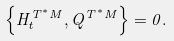<formula> <loc_0><loc_0><loc_500><loc_500>\left \{ H _ { t } ^ { T ^ { * } M } , Q ^ { T ^ { * } M } \right \} = 0 .</formula> 